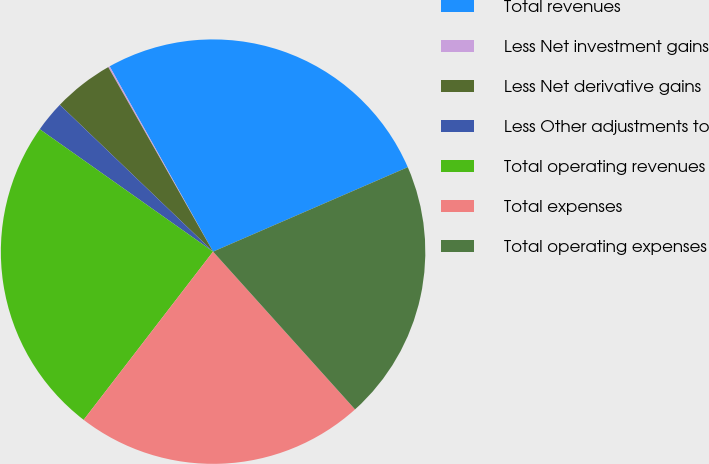<chart> <loc_0><loc_0><loc_500><loc_500><pie_chart><fcel>Total revenues<fcel>Less Net investment gains<fcel>Less Net derivative gains<fcel>Less Other adjustments to<fcel>Total operating revenues<fcel>Total expenses<fcel>Total operating expenses<nl><fcel>26.59%<fcel>0.12%<fcel>4.62%<fcel>2.37%<fcel>24.35%<fcel>22.1%<fcel>19.85%<nl></chart> 